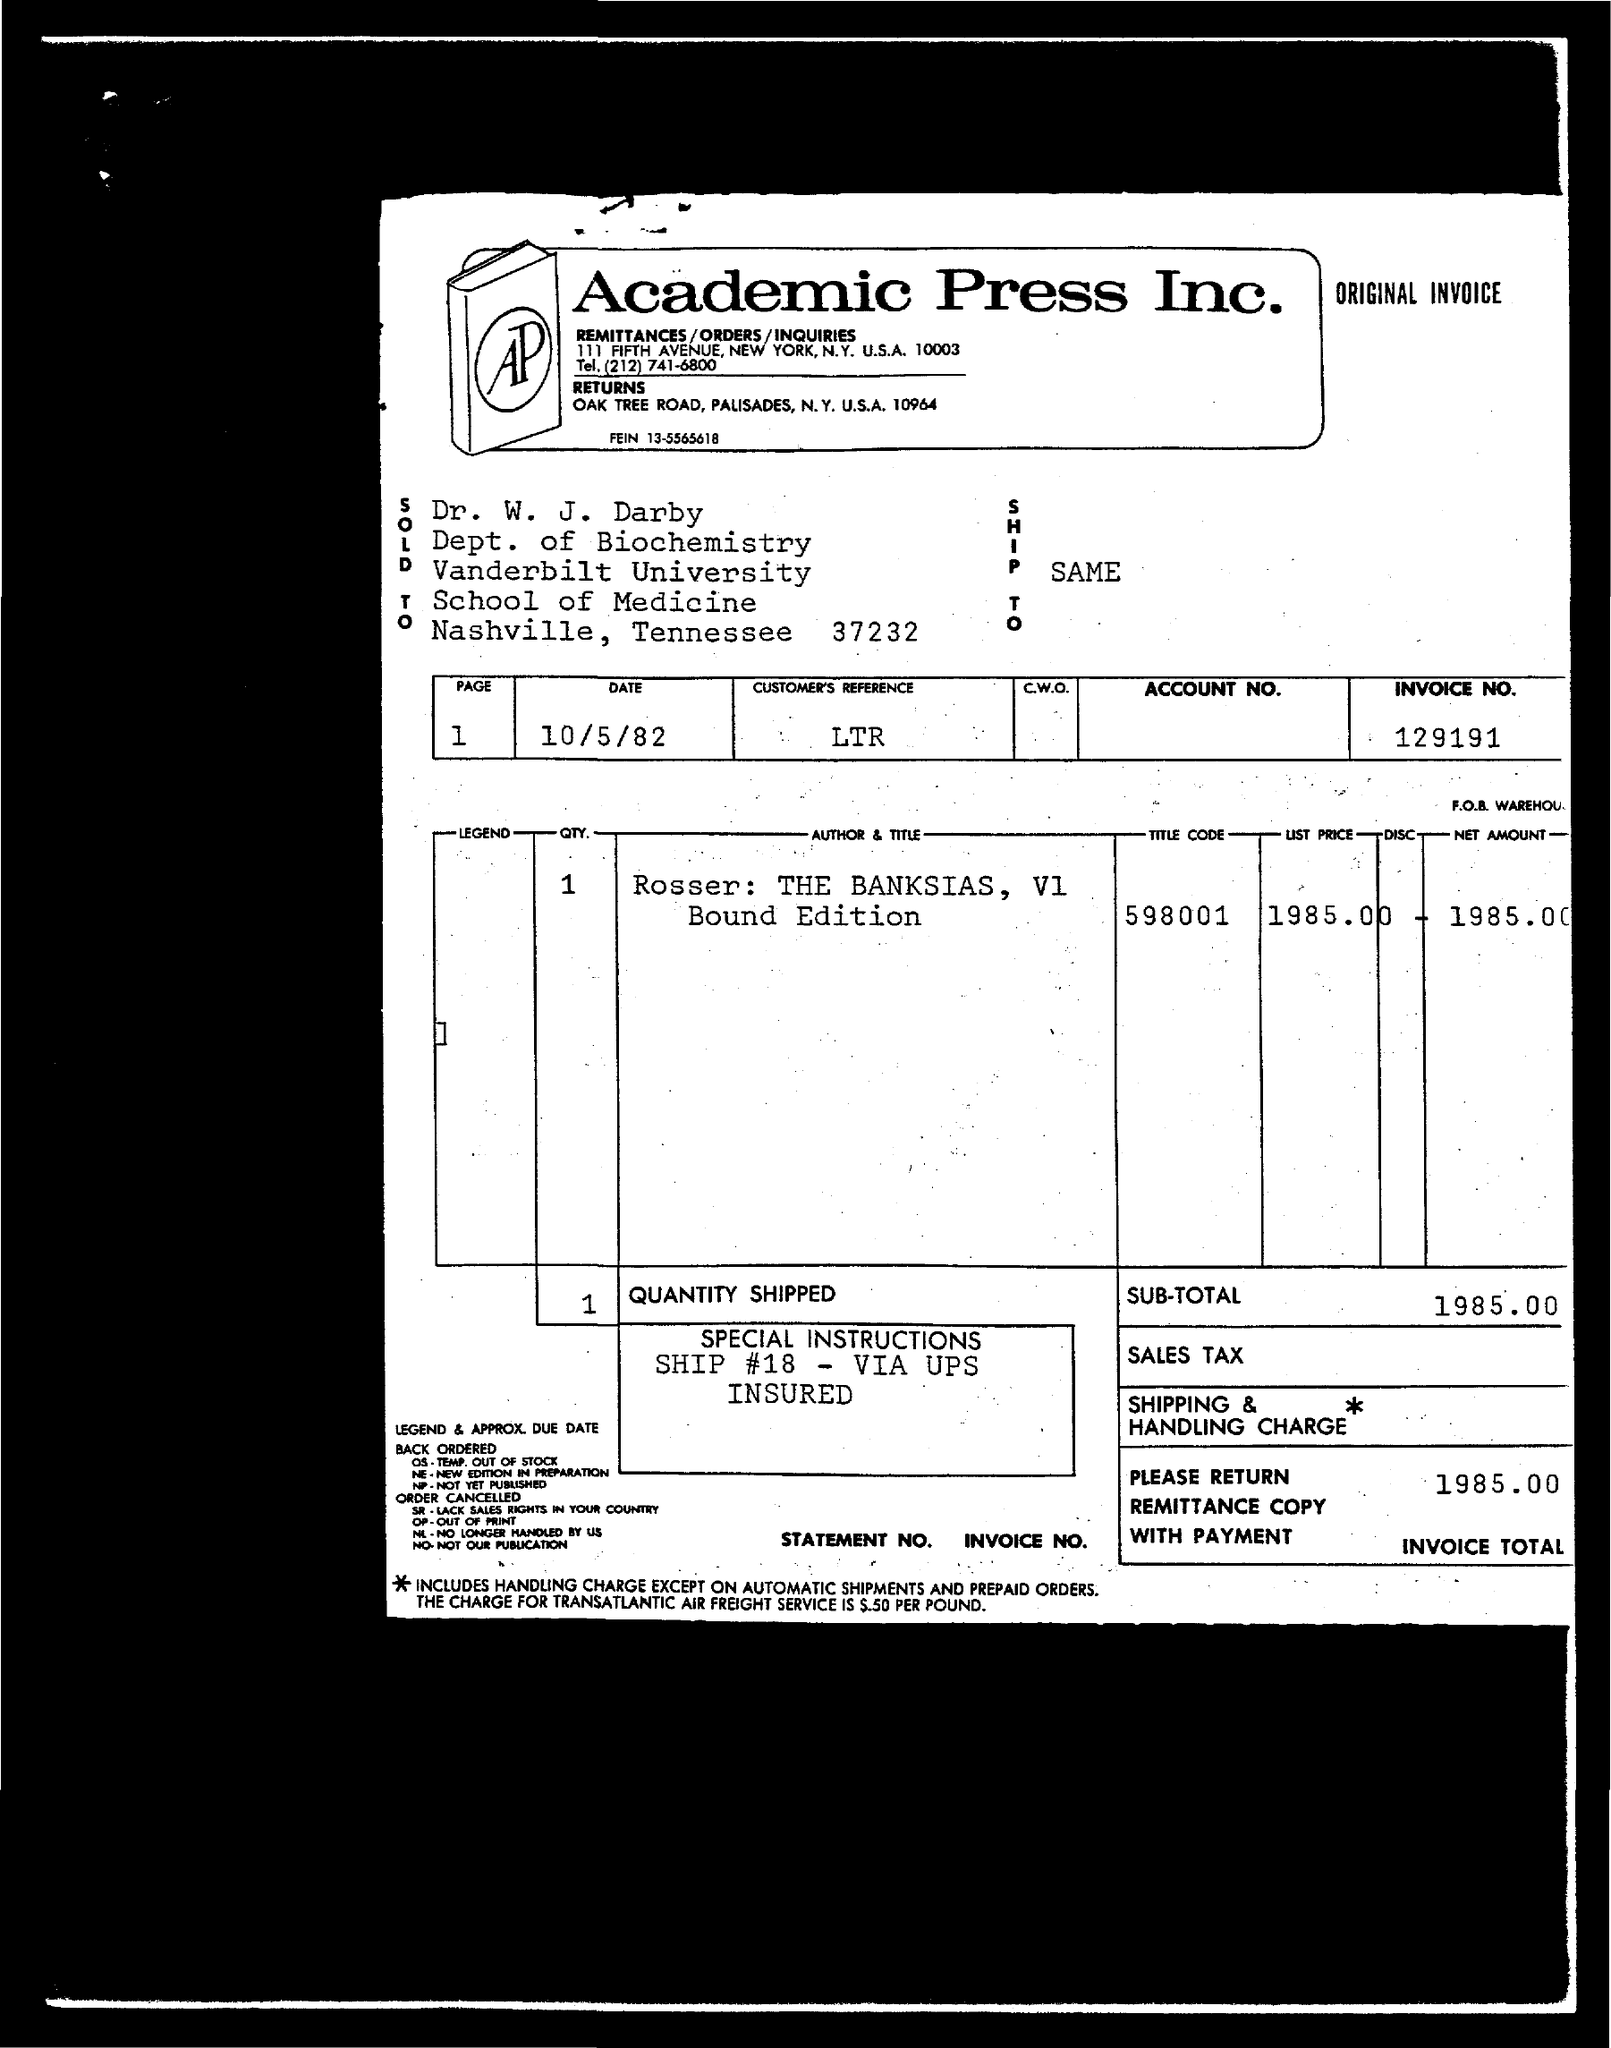What is the invoice total given in the document?
Your answer should be very brief. 1985.00. What is the Invoice No. given in the document?
Provide a succinct answer. 129191. In whose name, the invoice is issued?
Keep it short and to the point. Dr. W. J. Darby. What is the customer's reference given in the invoice?
Make the answer very short. LTR. What is the date mentioned in the invoice?
Your answer should be very brief. 10/5/82. What is the title code mentioned in the invoice?
Provide a short and direct response. 598001. What is the list price given in the invoice?
Keep it short and to the point. 1985.00. 